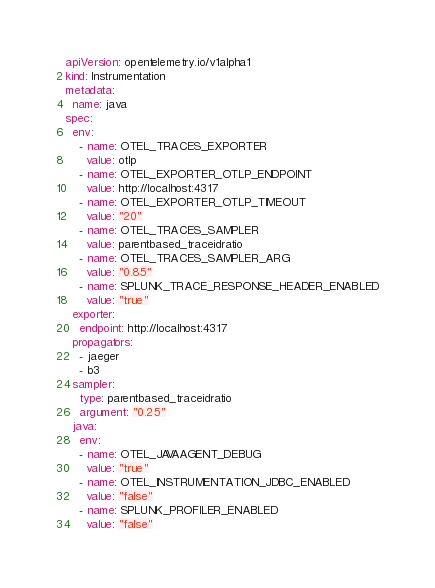Convert code to text. <code><loc_0><loc_0><loc_500><loc_500><_YAML_>apiVersion: opentelemetry.io/v1alpha1
kind: Instrumentation
metadata:
  name: java
spec:
  env:
    - name: OTEL_TRACES_EXPORTER
      value: otlp
    - name: OTEL_EXPORTER_OTLP_ENDPOINT
      value: http://localhost:4317
    - name: OTEL_EXPORTER_OTLP_TIMEOUT
      value: "20"
    - name: OTEL_TRACES_SAMPLER
      value: parentbased_traceidratio
    - name: OTEL_TRACES_SAMPLER_ARG
      value: "0.85"
    - name: SPLUNK_TRACE_RESPONSE_HEADER_ENABLED
      value: "true"
  exporter:
    endpoint: http://localhost:4317
  propagators:
    - jaeger
    - b3
  sampler:
    type: parentbased_traceidratio
    argument: "0.25"
  java:
    env:
    - name: OTEL_JAVAAGENT_DEBUG
      value: "true"
    - name: OTEL_INSTRUMENTATION_JDBC_ENABLED
      value: "false"
    - name: SPLUNK_PROFILER_ENABLED
      value: "false"
</code> 